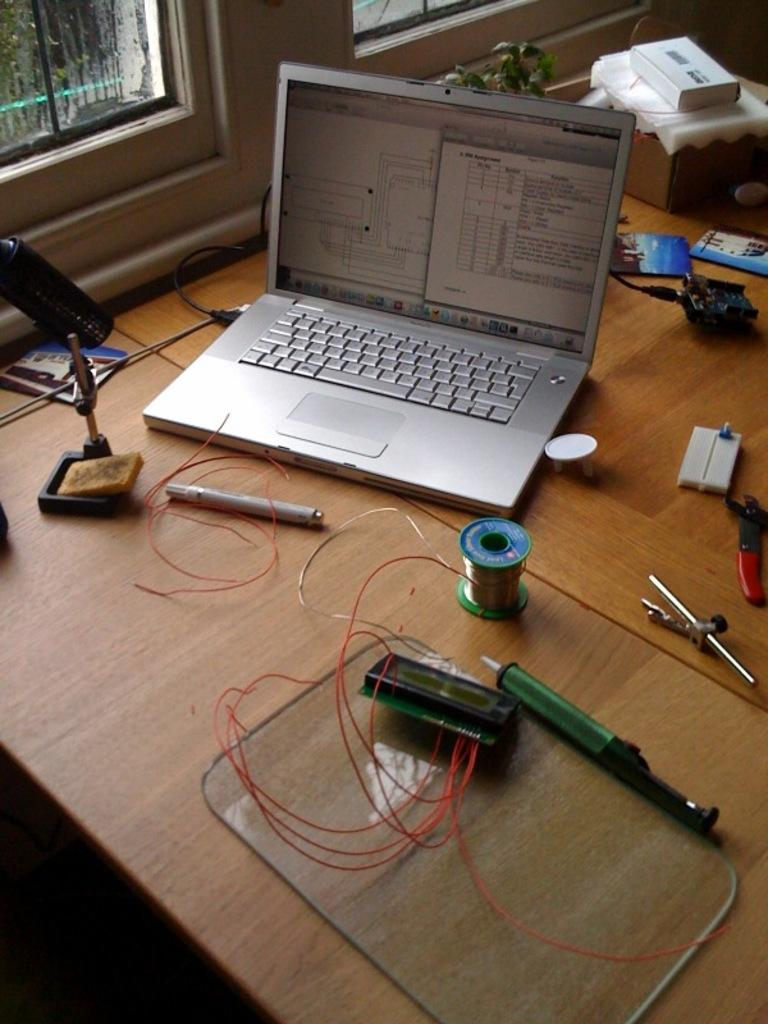What type of table is in the image? There is a round table in the image. What electronic device is on the table? A laptop is present on the table. What else can be seen on the table? There is a wire, a screwdriver, and a small plant on the table. What is visible in the background of the image? There is a small window in the background of the image. How many cats are sitting on the laptop in the image? There are no cats present in the image; only a laptop, wire, screwdriver, and small plant are visible on the table. 